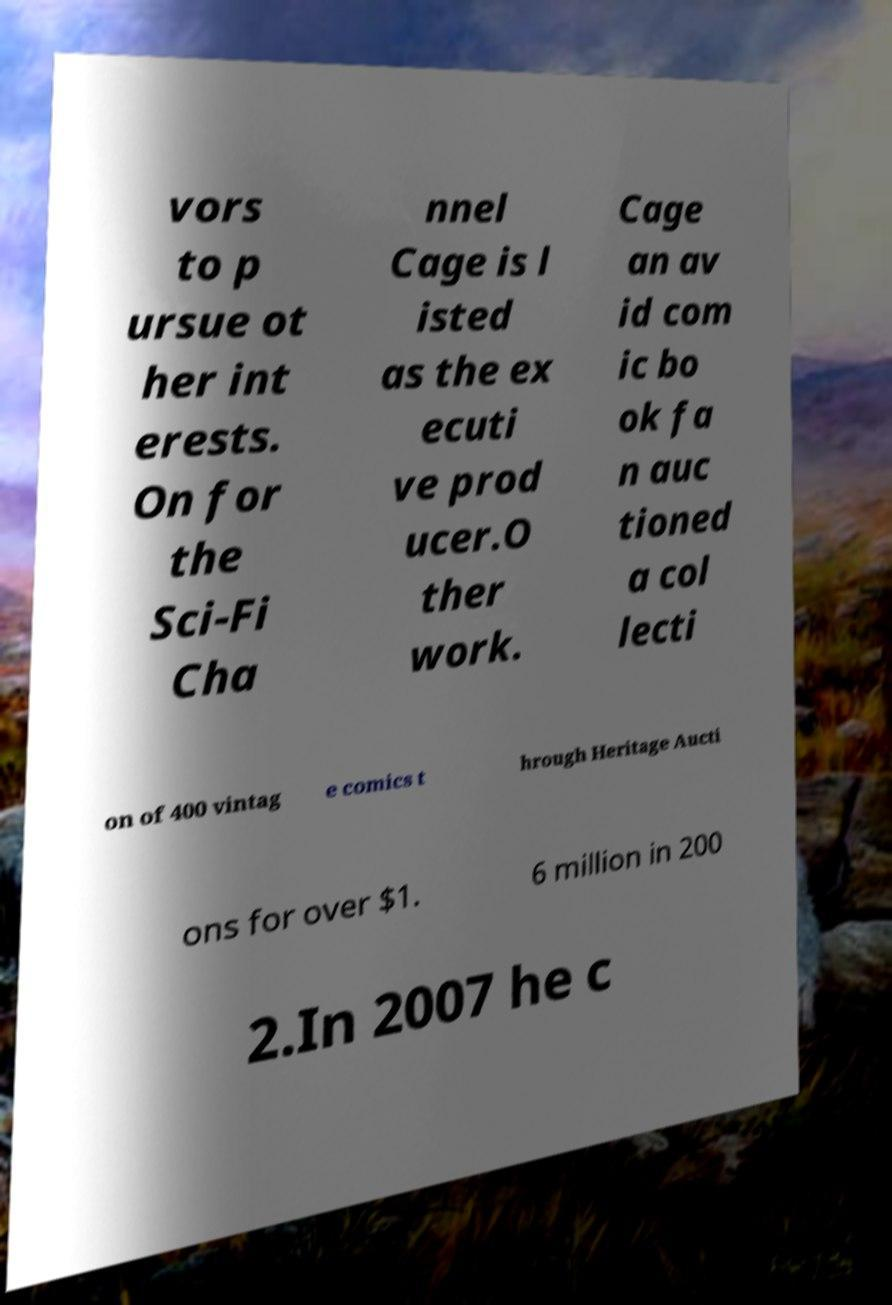There's text embedded in this image that I need extracted. Can you transcribe it verbatim? vors to p ursue ot her int erests. On for the Sci-Fi Cha nnel Cage is l isted as the ex ecuti ve prod ucer.O ther work. Cage an av id com ic bo ok fa n auc tioned a col lecti on of 400 vintag e comics t hrough Heritage Aucti ons for over $1. 6 million in 200 2.In 2007 he c 